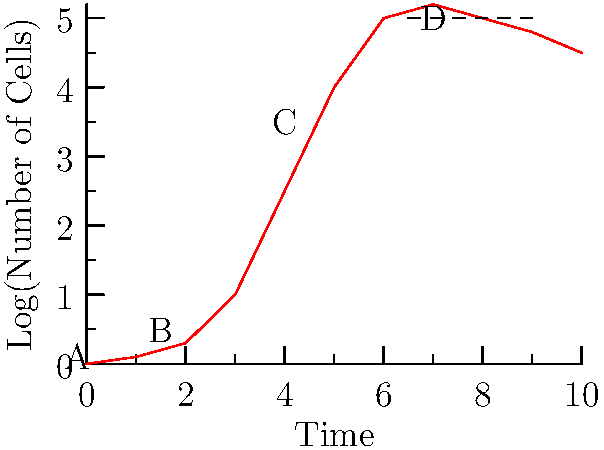Identify the phases of bacterial growth represented by labels A, B, C, and D in the given growth curve. To identify the phases of bacterial growth, let's analyze the curve step-by-step:

1. Phase A: This initial phase shows no significant increase in cell numbers. It represents the lag phase, where bacteria adapt to the new environment and prepare for growth.

2. Phase B: This phase shows a slight increase in cell numbers, but not yet exponential. It represents the acceleration phase, where bacteria begin to divide more rapidly.

3. Phase C: This phase shows a steep, linear increase in the logarithm of cell numbers. It represents the exponential (log) phase, where bacteria divide at their maximum rate.

4. Phase D: This phase shows a plateau in cell numbers, indicating no net increase. It represents the stationary phase, where the growth rate equals the death rate due to nutrient depletion or accumulation of toxic byproducts.

The curve also hints at a fifth phase after D, where cell numbers begin to decrease slightly, which would represent the death phase.
Answer: A: Lag phase, B: Acceleration phase, C: Exponential phase, D: Stationary phase 